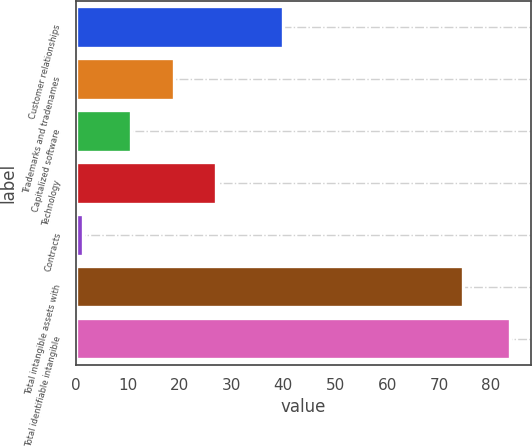Convert chart. <chart><loc_0><loc_0><loc_500><loc_500><bar_chart><fcel>Customer relationships<fcel>Trademarks and tradenames<fcel>Capitalized software<fcel>Technology<fcel>Contracts<fcel>Total intangible assets with<fcel>Total identifiable intangible<nl><fcel>40<fcel>18.83<fcel>10.6<fcel>27.06<fcel>1.3<fcel>74.7<fcel>83.6<nl></chart> 